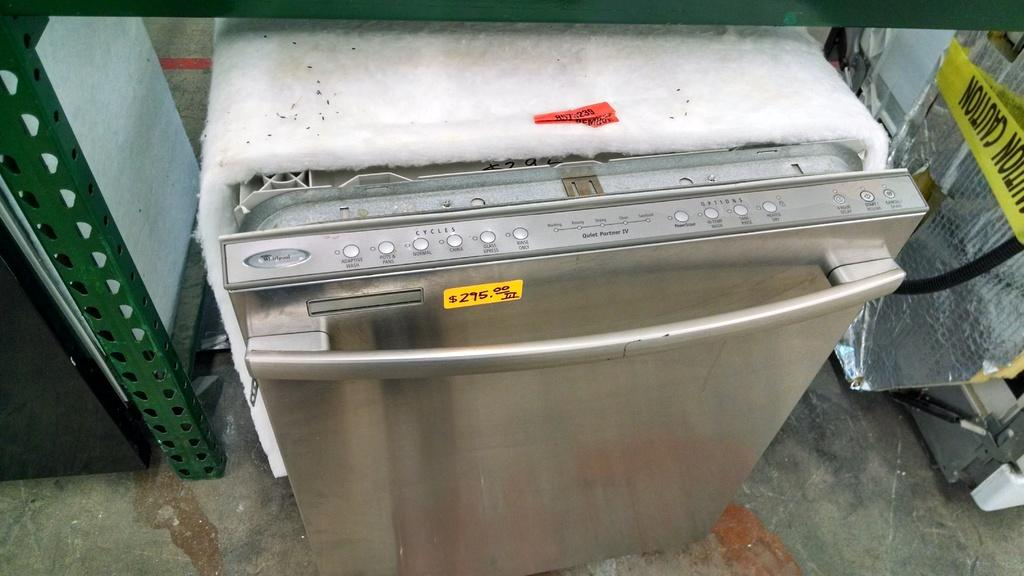<image>
Write a terse but informative summary of the picture. A stainless steel dishwasher is on sale for $295. 